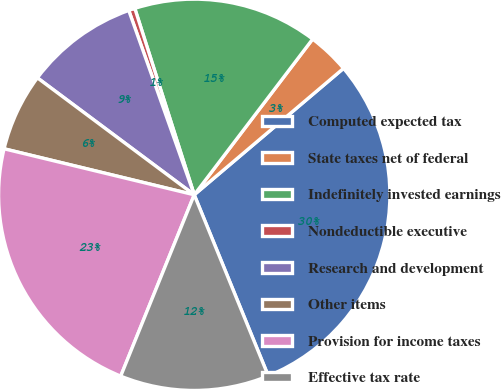Convert chart. <chart><loc_0><loc_0><loc_500><loc_500><pie_chart><fcel>Computed expected tax<fcel>State taxes net of federal<fcel>Indefinitely invested earnings<fcel>Nondeductible executive<fcel>Research and development<fcel>Other items<fcel>Provision for income taxes<fcel>Effective tax rate<nl><fcel>30.01%<fcel>3.47%<fcel>15.26%<fcel>0.52%<fcel>9.37%<fcel>6.42%<fcel>22.65%<fcel>12.31%<nl></chart> 